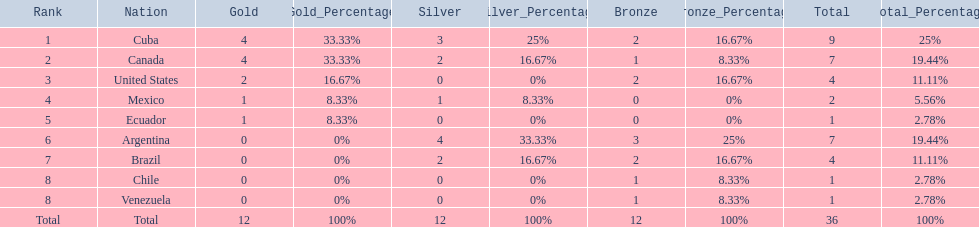Which nations participated? Cuba, Canada, United States, Mexico, Ecuador, Argentina, Brazil, Chile, Venezuela. Which nations won gold? Cuba, Canada, United States, Mexico, Ecuador. Which nations did not win silver? United States, Ecuador, Chile, Venezuela. Out of those countries previously listed, which nation won gold? United States. 